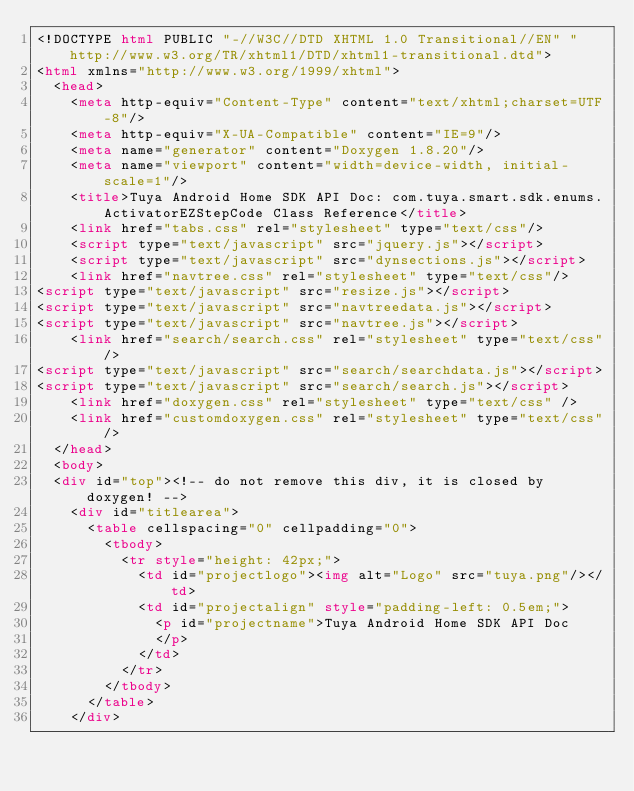Convert code to text. <code><loc_0><loc_0><loc_500><loc_500><_HTML_><!DOCTYPE html PUBLIC "-//W3C//DTD XHTML 1.0 Transitional//EN" "http://www.w3.org/TR/xhtml1/DTD/xhtml1-transitional.dtd">
<html xmlns="http://www.w3.org/1999/xhtml">
	<head>
		<meta http-equiv="Content-Type" content="text/xhtml;charset=UTF-8"/>
		<meta http-equiv="X-UA-Compatible" content="IE=9"/>
		<meta name="generator" content="Doxygen 1.8.20"/>
		<meta name="viewport" content="width=device-width, initial-scale=1"/>
		<title>Tuya Android Home SDK API Doc: com.tuya.smart.sdk.enums.ActivatorEZStepCode Class Reference</title>
		<link href="tabs.css" rel="stylesheet" type="text/css"/>
		<script type="text/javascript" src="jquery.js"></script>
		<script type="text/javascript" src="dynsections.js"></script>
		<link href="navtree.css" rel="stylesheet" type="text/css"/>
<script type="text/javascript" src="resize.js"></script>
<script type="text/javascript" src="navtreedata.js"></script>
<script type="text/javascript" src="navtree.js"></script>
		<link href="search/search.css" rel="stylesheet" type="text/css"/>
<script type="text/javascript" src="search/searchdata.js"></script>
<script type="text/javascript" src="search/search.js"></script>
		<link href="doxygen.css" rel="stylesheet" type="text/css" />
		<link href="customdoxygen.css" rel="stylesheet" type="text/css"/>
	</head>
	<body>
	<div id="top"><!-- do not remove this div, it is closed by doxygen! -->
		<div id="titlearea">
			<table cellspacing="0" cellpadding="0">
				<tbody>
					<tr style="height: 42px;">
						<td id="projectlogo"><img alt="Logo" src="tuya.png"/></td>
						<td id="projectalign" style="padding-left: 0.5em;">
							<p id="projectname">Tuya Android Home SDK API Doc
							</p>
						</td>
					</tr>
				</tbody>
			</table>
		</div></code> 